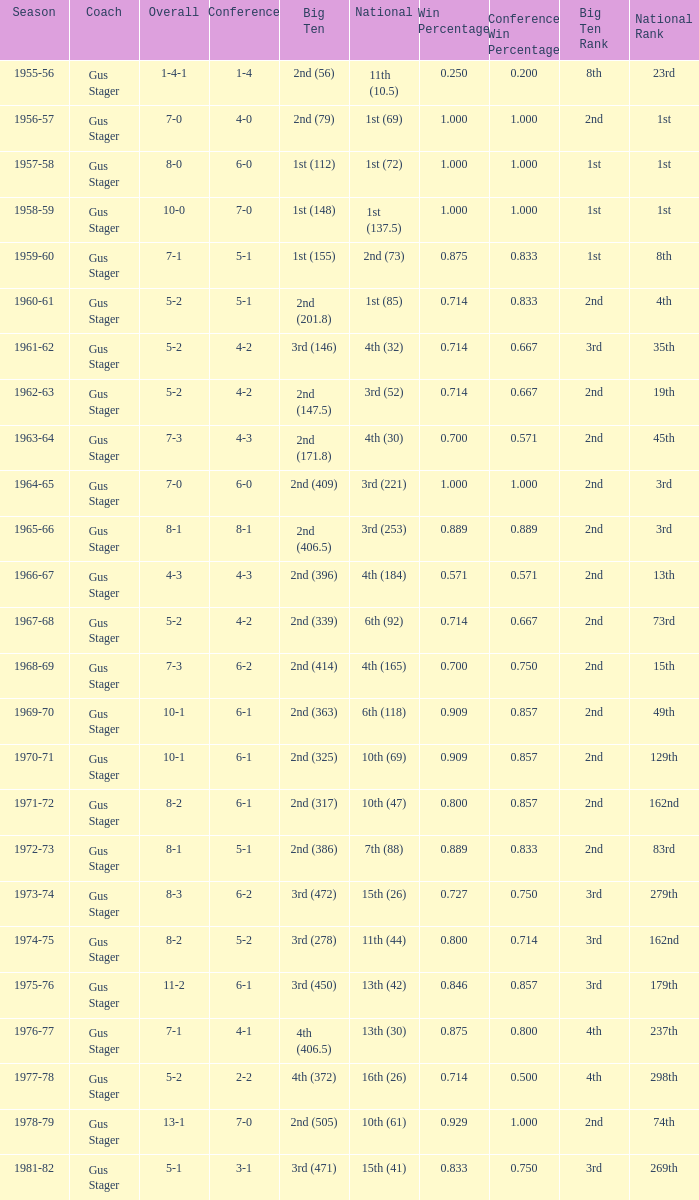What is the Coach with a Big Ten that is 2nd (79)? Gus Stager. 